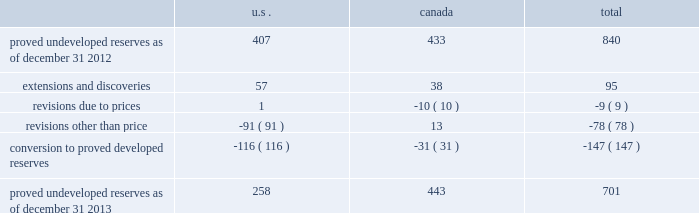Devon energy corporation and subsidiaries notes to consolidated financial statements 2013 ( continued ) proved undeveloped reserves the table presents the changes in devon 2019s total proved undeveloped reserves during 2013 ( in mmboe ) . .
At december 31 , 2013 , devon had 701 mmboe of proved undeveloped reserves .
This represents a 17 percent decrease as compared to 2012 and represents 24 percent of total proved reserves .
Drilling and development activities increased devon 2019s proved undeveloped reserves 95 mmboe and resulted in the conversion of 147 mmboe , or 18 percent , of the 2012 proved undeveloped reserves to proved developed reserves .
Costs incurred related to the development and conversion of devon 2019s proved undeveloped reserves were $ 1.9 billion for 2013 .
Additionally , revisions other than price decreased devon 2019s proved undeveloped reserves 78 mmboe primarily due to evaluations of certain u.s .
Onshore dry-gas areas , which devon does not expect to develop in the next five years .
The largest revisions relate to the dry-gas areas in the cana-woodford shale in western oklahoma , carthage in east texas and the barnett shale in north texas .
A significant amount of devon 2019s proved undeveloped reserves at the end of 2013 related to its jackfish operations .
At december 31 , 2013 and 2012 , devon 2019s jackfish proved undeveloped reserves were 441 mmboe and 429 mmboe , respectively .
Development schedules for the jackfish reserves are primarily controlled by the need to keep the processing plants at their 35000 barrel daily facility capacity .
Processing plant capacity is controlled by factors such as total steam processing capacity , steam-oil ratios and air quality discharge permits .
As a result , these reserves are classified as proved undeveloped for more than five years .
Currently , the development schedule for these reserves extends though the year 2031 .
Price revisions 2013 2013 reserves increased 94 mmboe primarily due to higher gas prices .
Of this increase , 43 mmboe related to the barnett shale and 19 mmboe related to the rocky mountain area .
2012 2013 reserves decreased 171 mmboe primarily due to lower gas prices .
Of this decrease , 100 mmboe related to the barnett shale and 25 mmboe related to the rocky mountain area .
2011 2013 reserves decreased 21 mmboe due to lower gas prices and higher oil prices .
The higher oil prices increased devon 2019s canadian royalty burden , which reduced devon 2019s oil reserves .
Revisions other than price total revisions other than price for 2013 , 2012 and 2011 primarily related to devon 2019s evaluation of certain dry gas regions , with the largest revisions being made in the cana-woodford shale , barnett shale and carthage .
As of december 31 2013 what was the percent of the proved undeveloped reserves in canada? 
Computations: (443 / 701)
Answer: 0.63195. 